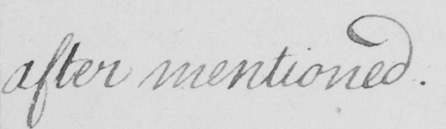Transcribe the text shown in this historical manuscript line. after mentioned . 